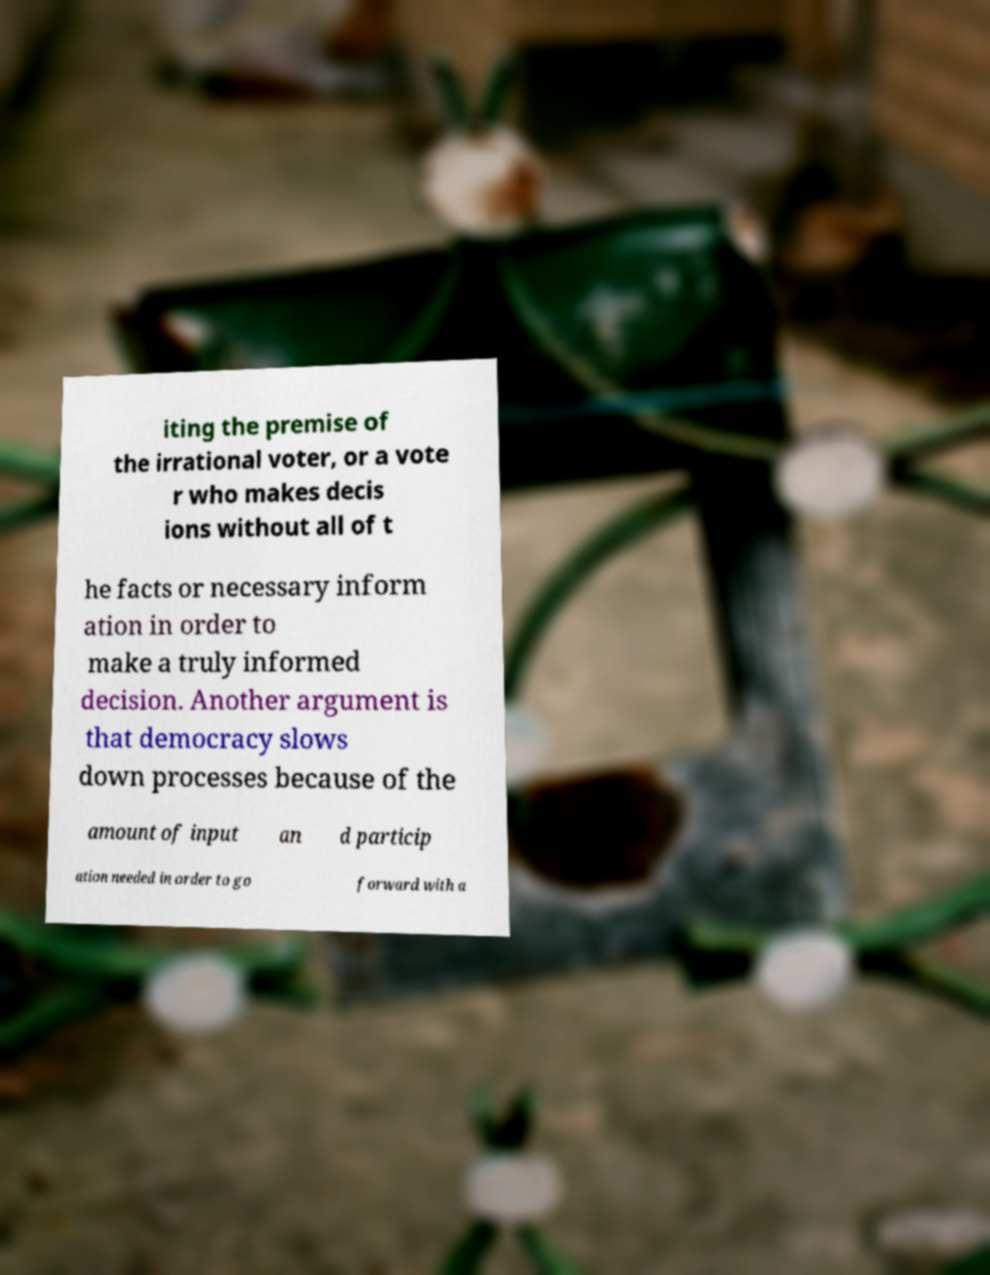There's text embedded in this image that I need extracted. Can you transcribe it verbatim? iting the premise of the irrational voter, or a vote r who makes decis ions without all of t he facts or necessary inform ation in order to make a truly informed decision. Another argument is that democracy slows down processes because of the amount of input an d particip ation needed in order to go forward with a 